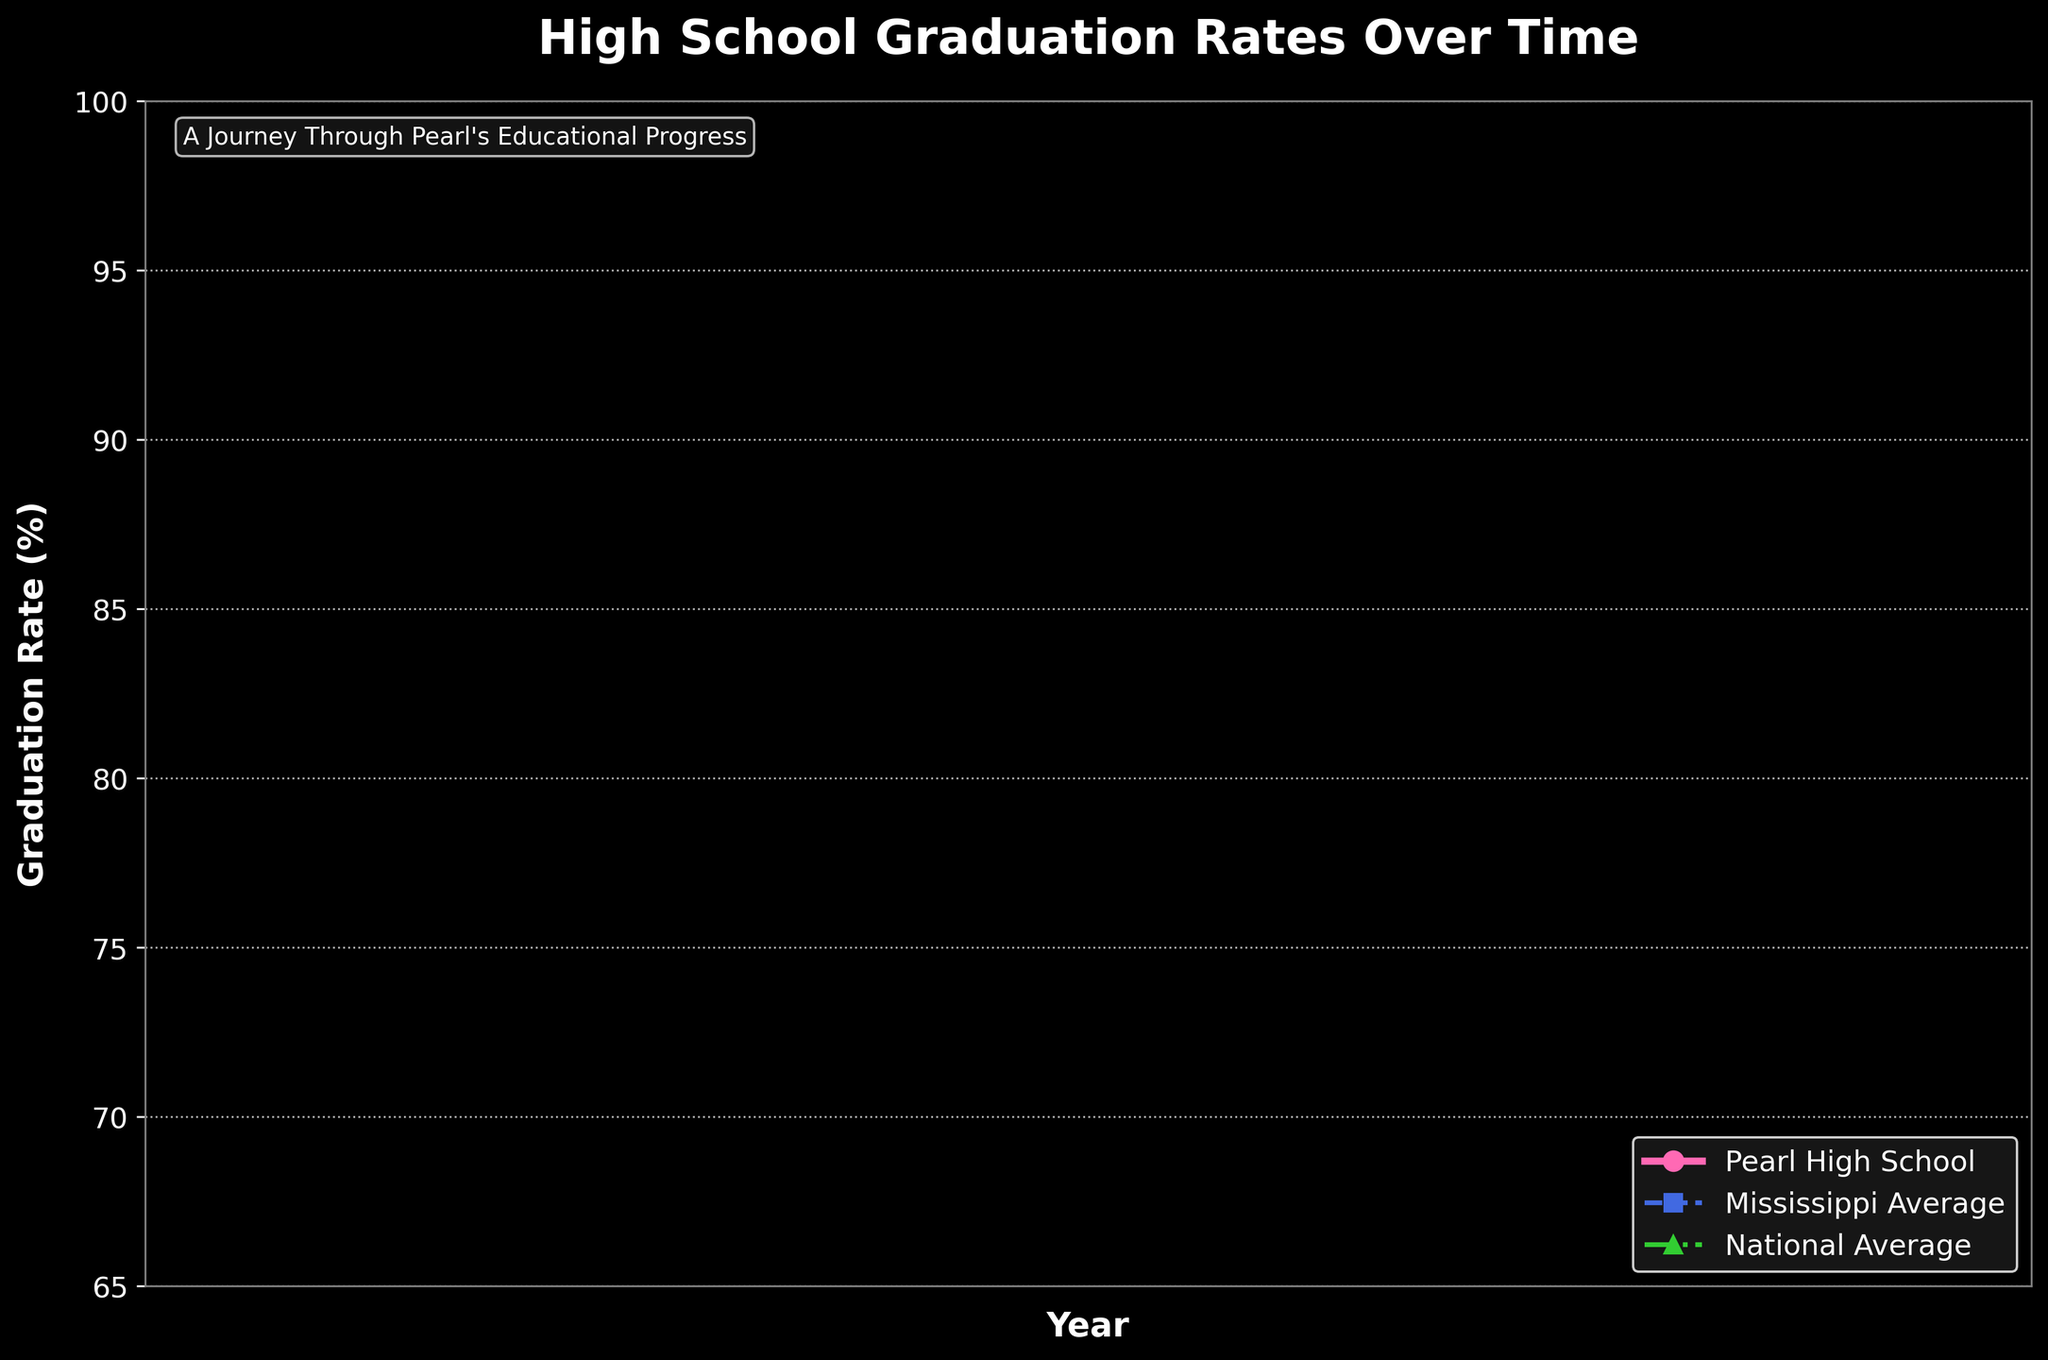Which year saw the largest increase in Pearl High School graduation rates compared to the previous year? To determine the largest increase, we need to calculate the year-over-year differences in graduation rates for Pearl High School: 84.1-82.5 (1965: 1.6), 86.3-84.1 (1970: 2.2), 88.7-86.3 (1975: 2.4), 90.2-88.7 (1980: 1.5), 91.8-90.2 (1985: 1.6), 93.1-91.8 (1990: 1.3), 94.5-93.1 (1995: 1.4), 95.7-94.5 (2000: 1.2), 96.3-95.7 (2005: 0.6), 97.1-96.3 (2010: 0.8), 97.8-97.1 (2015: 0.7), 98.2-97.8 (2020: 0.4), 98.5-98.2 (Present: 0.3). The largest increase occurred between 1970 and 1975, with an increase of 2.4%.
Answer: 1975 How does the 1960 graduation rate of Pearl High School compare to the national average in the same year? We look at the graduation rates for Pearl High School (82.5%) and the national average (72.4%) in the year 1960. To compare, we see that Pearl had a higher graduation rate than the national average by 10.1 percentage points.
Answer: Higher by 10.1 percentage points Which year did Mississippi's average graduation rate surpass 90%? By examining the data, we can see that Mississippi's average graduation rate exceeded 90% for the first time in 2020 (91.2%).
Answer: 2020 During which period did Pearl High School's graduation rates remain the closest to the national average? To find this, we compare the graduation rates of Pearl High School and the national average for each year and look for the smallest differences: 1960 (10.1), 1965 (9.3), 1970 (9.2), 1975 (9.2), 1980 (9.0), 1985 (8.2), 1990 (7.4), 1995 (7.2), 2000 (6.8), 2005 (6.1), 2010 (5.3), 2015 (4.7), 2020 (3.7), Present (3.2). The period with the smallest differences is from 2015 to present, with the smallest difference in the present year (3.2).
Answer: From 2015 to present How much higher was Pearl High School's graduation rate than Mississippi's average rate in the year 2000? In the year 2000, Pearl High School had a graduation rate of 95.7%, while Mississippi's average rate was 85.8%. The difference can be calculated by subtraction: 95.7 - 85.8 = 9.9 percentage points.
Answer: 9.9 percentage points What visual elements are used to differentiate the three data series in the chart? The chart uses different colors and markers for each data series: Pearl High School is marked with pink circles, Mississippi Average with blue squares and dashed lines, and the National Average with green triangles and dotted lines.
Answer: Colors, markers, and line styles Which decade saw the smallest overall improvement in graduation rates for Pearl High School? To determine this, we calculate the rate increase for each decade: 1960-1970 (86.3-82.5 = 3.8), 1970-1980 (90.2-86.3 = 3.9), 1980-1990 (93.1-90.2 = 2.9), 1990-2000 (95.7-93.1 = 2.6), 2000-2010 (97.1-95.7 = 1.4), 2010-Present (98.5-97.1 = 1.4). Pearl High School saw the smallest improvement in the periods from 2000-2010 and 2010-Present, both with an increase of 1.4 percentage points each.
Answer: 2000-2010 and 2010-Present How does the rate of increase in graduation rates for Pearl High School from 1985 to 1990 compare to that of the national average in the same period? We calculate the rate increases: for Pearl High School (93.1-91.8 = 1.3), for the national average (85.7-83.6 = 2.1). The national average rate increased faster by 0.8 percentage points in that period.
Answer: National average increased faster by 0.8 percentage points 